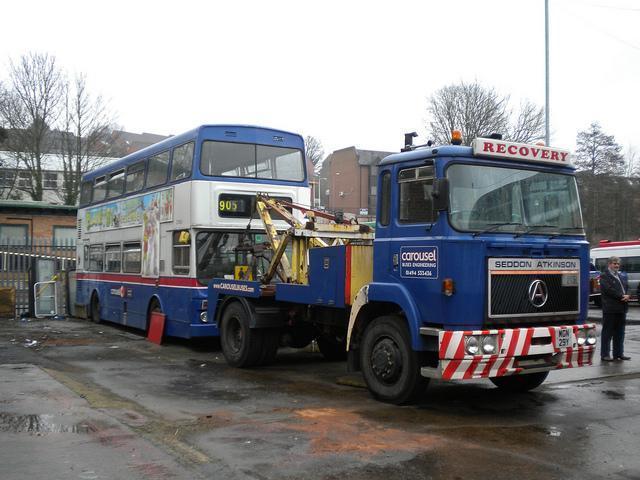How many buses are there?
Give a very brief answer. 1. 